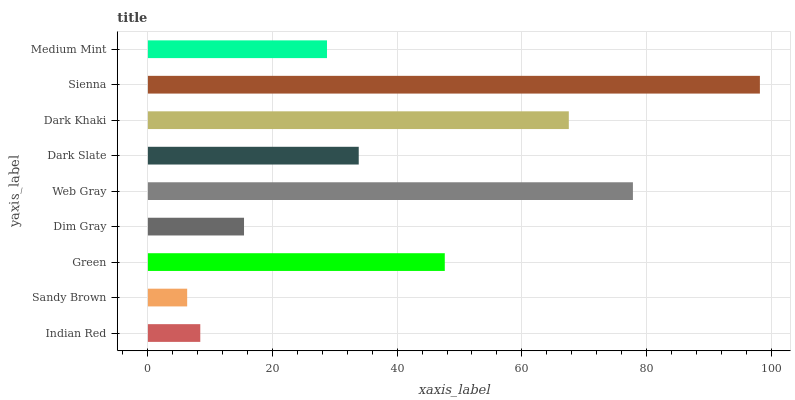Is Sandy Brown the minimum?
Answer yes or no. Yes. Is Sienna the maximum?
Answer yes or no. Yes. Is Green the minimum?
Answer yes or no. No. Is Green the maximum?
Answer yes or no. No. Is Green greater than Sandy Brown?
Answer yes or no. Yes. Is Sandy Brown less than Green?
Answer yes or no. Yes. Is Sandy Brown greater than Green?
Answer yes or no. No. Is Green less than Sandy Brown?
Answer yes or no. No. Is Dark Slate the high median?
Answer yes or no. Yes. Is Dark Slate the low median?
Answer yes or no. Yes. Is Sandy Brown the high median?
Answer yes or no. No. Is Web Gray the low median?
Answer yes or no. No. 